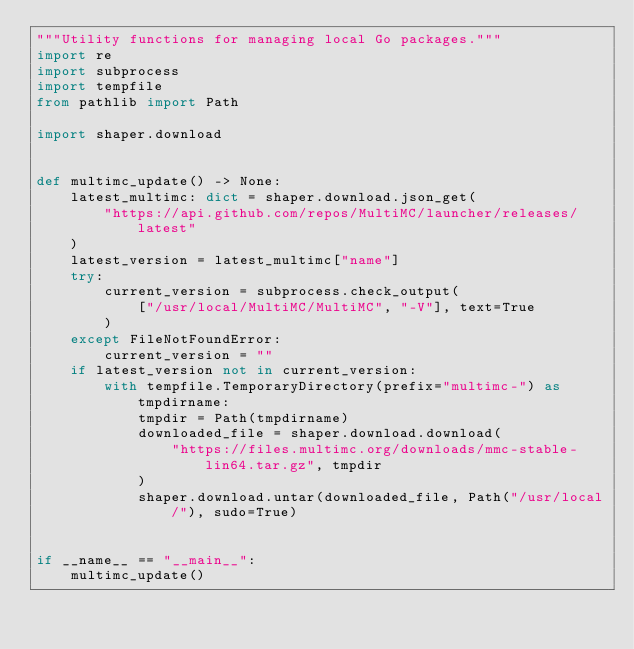<code> <loc_0><loc_0><loc_500><loc_500><_Python_>"""Utility functions for managing local Go packages."""
import re
import subprocess
import tempfile
from pathlib import Path

import shaper.download


def multimc_update() -> None:
    latest_multimc: dict = shaper.download.json_get(
        "https://api.github.com/repos/MultiMC/launcher/releases/latest"
    )
    latest_version = latest_multimc["name"]
    try:
        current_version = subprocess.check_output(
            ["/usr/local/MultiMC/MultiMC", "-V"], text=True
        )
    except FileNotFoundError:
        current_version = ""
    if latest_version not in current_version:
        with tempfile.TemporaryDirectory(prefix="multimc-") as tmpdirname:
            tmpdir = Path(tmpdirname)
            downloaded_file = shaper.download.download(
                "https://files.multimc.org/downloads/mmc-stable-lin64.tar.gz", tmpdir
            )
            shaper.download.untar(downloaded_file, Path("/usr/local/"), sudo=True)


if __name__ == "__main__":
    multimc_update()
</code> 